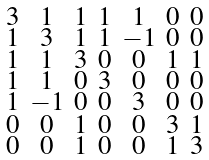<formula> <loc_0><loc_0><loc_500><loc_500>\begin{smallmatrix} 3 & 1 & 1 & 1 & 1 & 0 & 0 \\ 1 & 3 & 1 & 1 & - 1 & 0 & 0 \\ 1 & 1 & 3 & 0 & 0 & 1 & 1 \\ 1 & 1 & 0 & 3 & 0 & 0 & 0 \\ 1 & - 1 & 0 & 0 & 3 & 0 & 0 \\ 0 & 0 & 1 & 0 & 0 & 3 & 1 \\ 0 & 0 & 1 & 0 & 0 & 1 & 3 \end{smallmatrix}</formula> 